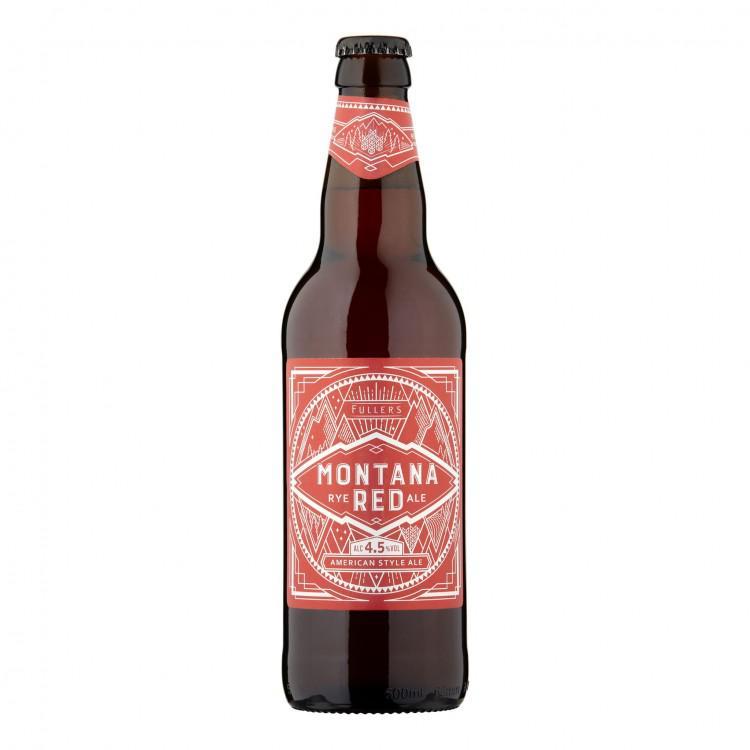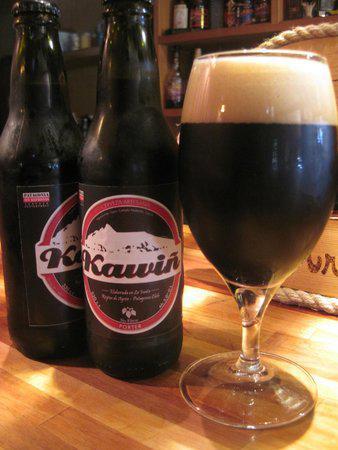The first image is the image on the left, the second image is the image on the right. Given the left and right images, does the statement "All beverage bottles have labels around both the body and neck of the bottle." hold true? Answer yes or no. No. The first image is the image on the left, the second image is the image on the right. Analyze the images presented: Is the assertion "At least one beer bottle is posed in front of a beach sunset, in one image." valid? Answer yes or no. No. 